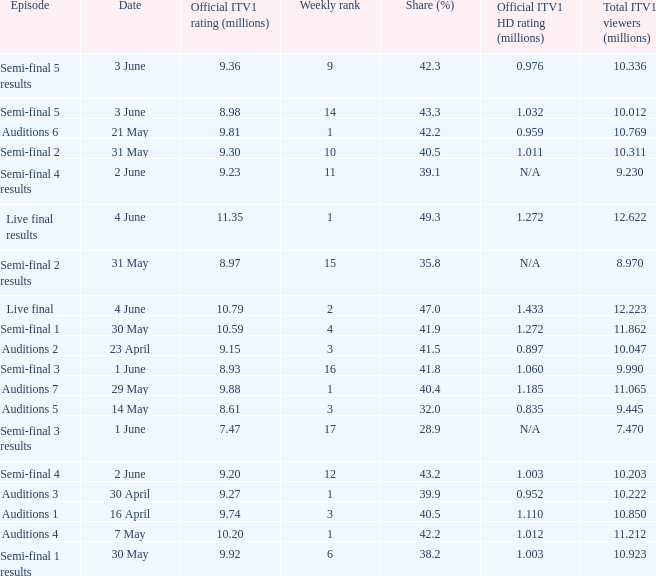What was the share (%) for the Semi-Final 2 episode?  40.5. 